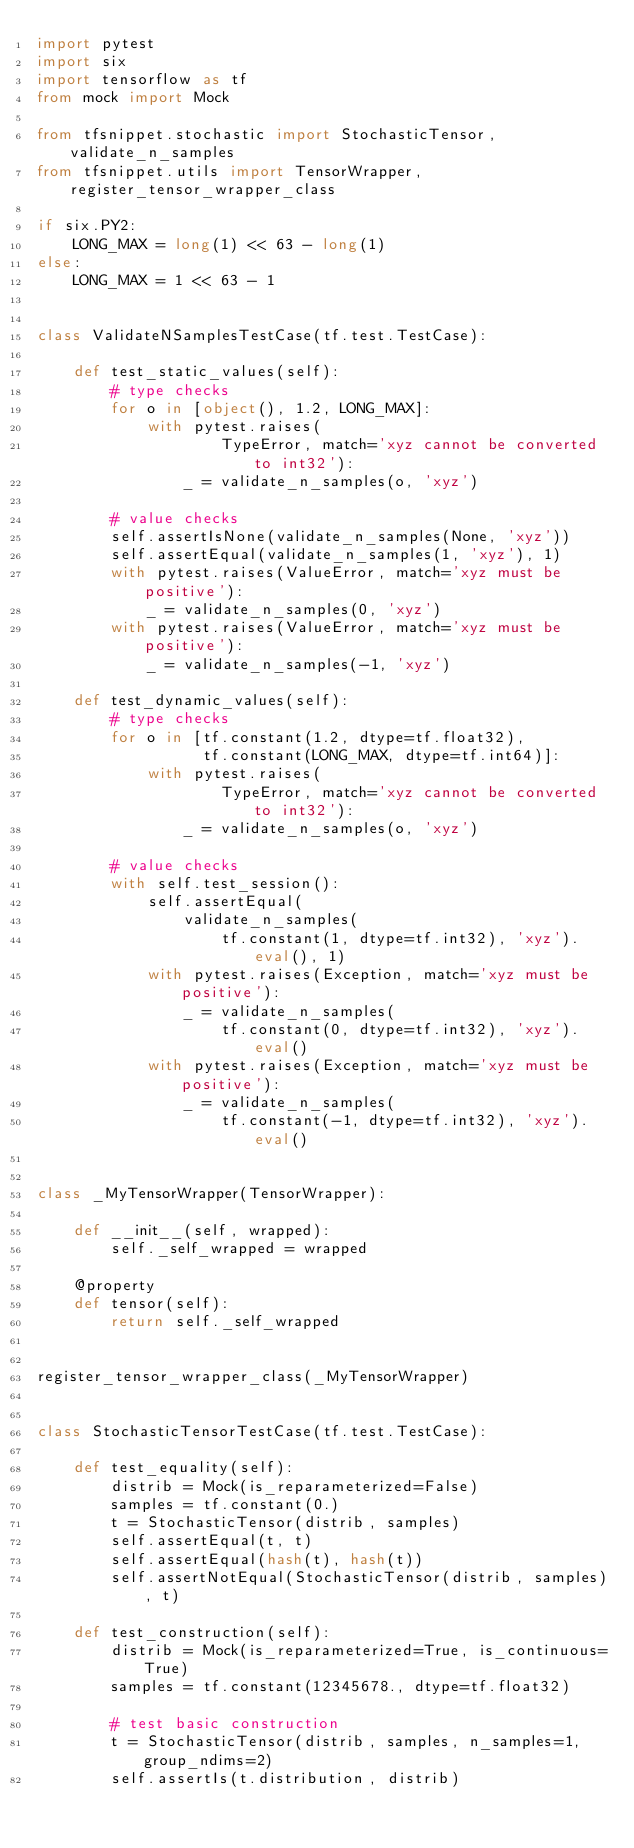Convert code to text. <code><loc_0><loc_0><loc_500><loc_500><_Python_>import pytest
import six
import tensorflow as tf
from mock import Mock

from tfsnippet.stochastic import StochasticTensor, validate_n_samples
from tfsnippet.utils import TensorWrapper, register_tensor_wrapper_class

if six.PY2:
    LONG_MAX = long(1) << 63 - long(1)
else:
    LONG_MAX = 1 << 63 - 1


class ValidateNSamplesTestCase(tf.test.TestCase):

    def test_static_values(self):
        # type checks
        for o in [object(), 1.2, LONG_MAX]:
            with pytest.raises(
                    TypeError, match='xyz cannot be converted to int32'):
                _ = validate_n_samples(o, 'xyz')

        # value checks
        self.assertIsNone(validate_n_samples(None, 'xyz'))
        self.assertEqual(validate_n_samples(1, 'xyz'), 1)
        with pytest.raises(ValueError, match='xyz must be positive'):
            _ = validate_n_samples(0, 'xyz')
        with pytest.raises(ValueError, match='xyz must be positive'):
            _ = validate_n_samples(-1, 'xyz')

    def test_dynamic_values(self):
        # type checks
        for o in [tf.constant(1.2, dtype=tf.float32),
                  tf.constant(LONG_MAX, dtype=tf.int64)]:
            with pytest.raises(
                    TypeError, match='xyz cannot be converted to int32'):
                _ = validate_n_samples(o, 'xyz')

        # value checks
        with self.test_session():
            self.assertEqual(
                validate_n_samples(
                    tf.constant(1, dtype=tf.int32), 'xyz').eval(), 1)
            with pytest.raises(Exception, match='xyz must be positive'):
                _ = validate_n_samples(
                    tf.constant(0, dtype=tf.int32), 'xyz').eval()
            with pytest.raises(Exception, match='xyz must be positive'):
                _ = validate_n_samples(
                    tf.constant(-1, dtype=tf.int32), 'xyz').eval()


class _MyTensorWrapper(TensorWrapper):

    def __init__(self, wrapped):
        self._self_wrapped = wrapped

    @property
    def tensor(self):
        return self._self_wrapped


register_tensor_wrapper_class(_MyTensorWrapper)


class StochasticTensorTestCase(tf.test.TestCase):

    def test_equality(self):
        distrib = Mock(is_reparameterized=False)
        samples = tf.constant(0.)
        t = StochasticTensor(distrib, samples)
        self.assertEqual(t, t)
        self.assertEqual(hash(t), hash(t))
        self.assertNotEqual(StochasticTensor(distrib, samples), t)

    def test_construction(self):
        distrib = Mock(is_reparameterized=True, is_continuous=True)
        samples = tf.constant(12345678., dtype=tf.float32)

        # test basic construction
        t = StochasticTensor(distrib, samples, n_samples=1, group_ndims=2)
        self.assertIs(t.distribution, distrib)</code> 